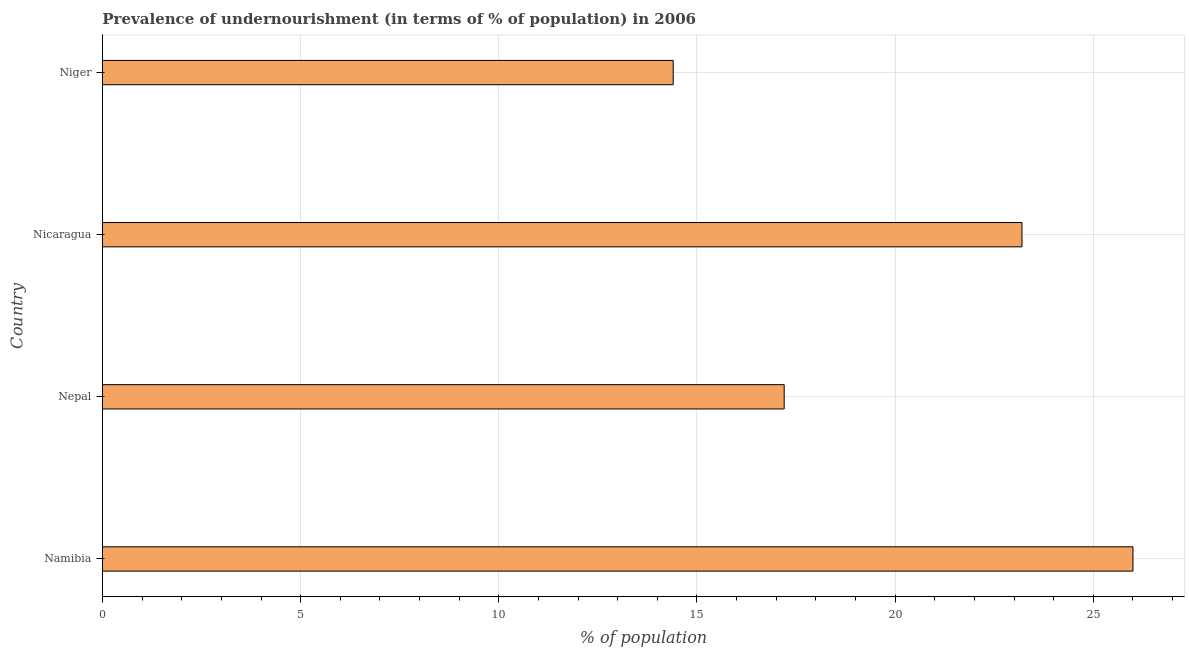Does the graph contain grids?
Your response must be concise. Yes. What is the title of the graph?
Your response must be concise. Prevalence of undernourishment (in terms of % of population) in 2006. What is the label or title of the X-axis?
Provide a short and direct response. % of population. What is the percentage of undernourished population in Nicaragua?
Provide a succinct answer. 23.2. In which country was the percentage of undernourished population maximum?
Your answer should be very brief. Namibia. In which country was the percentage of undernourished population minimum?
Provide a short and direct response. Niger. What is the sum of the percentage of undernourished population?
Your response must be concise. 80.8. What is the difference between the percentage of undernourished population in Namibia and Nicaragua?
Give a very brief answer. 2.8. What is the average percentage of undernourished population per country?
Provide a succinct answer. 20.2. What is the median percentage of undernourished population?
Provide a short and direct response. 20.2. What is the ratio of the percentage of undernourished population in Namibia to that in Niger?
Give a very brief answer. 1.81. What is the difference between the highest and the second highest percentage of undernourished population?
Offer a terse response. 2.8. Is the sum of the percentage of undernourished population in Nepal and Niger greater than the maximum percentage of undernourished population across all countries?
Give a very brief answer. Yes. What is the difference between the highest and the lowest percentage of undernourished population?
Your answer should be very brief. 11.6. Are all the bars in the graph horizontal?
Your response must be concise. Yes. How many countries are there in the graph?
Offer a very short reply. 4. What is the % of population of Nepal?
Offer a terse response. 17.2. What is the % of population in Nicaragua?
Offer a very short reply. 23.2. What is the % of population of Niger?
Your response must be concise. 14.4. What is the difference between the % of population in Namibia and Nepal?
Your response must be concise. 8.8. What is the difference between the % of population in Namibia and Niger?
Keep it short and to the point. 11.6. What is the difference between the % of population in Nicaragua and Niger?
Make the answer very short. 8.8. What is the ratio of the % of population in Namibia to that in Nepal?
Give a very brief answer. 1.51. What is the ratio of the % of population in Namibia to that in Nicaragua?
Ensure brevity in your answer.  1.12. What is the ratio of the % of population in Namibia to that in Niger?
Offer a very short reply. 1.81. What is the ratio of the % of population in Nepal to that in Nicaragua?
Provide a succinct answer. 0.74. What is the ratio of the % of population in Nepal to that in Niger?
Your response must be concise. 1.19. What is the ratio of the % of population in Nicaragua to that in Niger?
Provide a short and direct response. 1.61. 